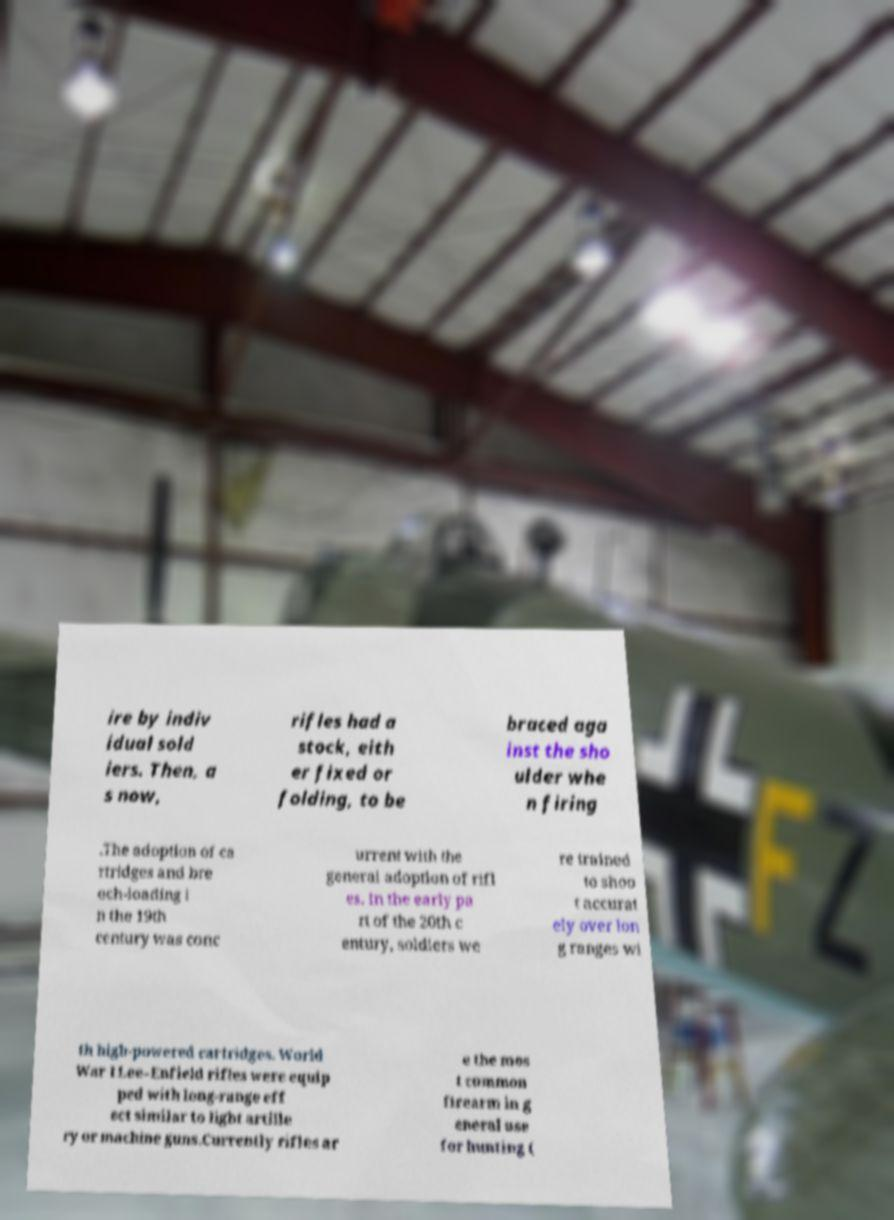There's text embedded in this image that I need extracted. Can you transcribe it verbatim? ire by indiv idual sold iers. Then, a s now, rifles had a stock, eith er fixed or folding, to be braced aga inst the sho ulder whe n firing .The adoption of ca rtridges and bre ech-loading i n the 19th century was conc urrent with the general adoption of rifl es. In the early pa rt of the 20th c entury, soldiers we re trained to shoo t accurat ely over lon g ranges wi th high-powered cartridges. World War I Lee–Enfield rifles were equip ped with long-range eff ect similar to light artille ry or machine guns.Currently rifles ar e the mos t common firearm in g eneral use for hunting ( 